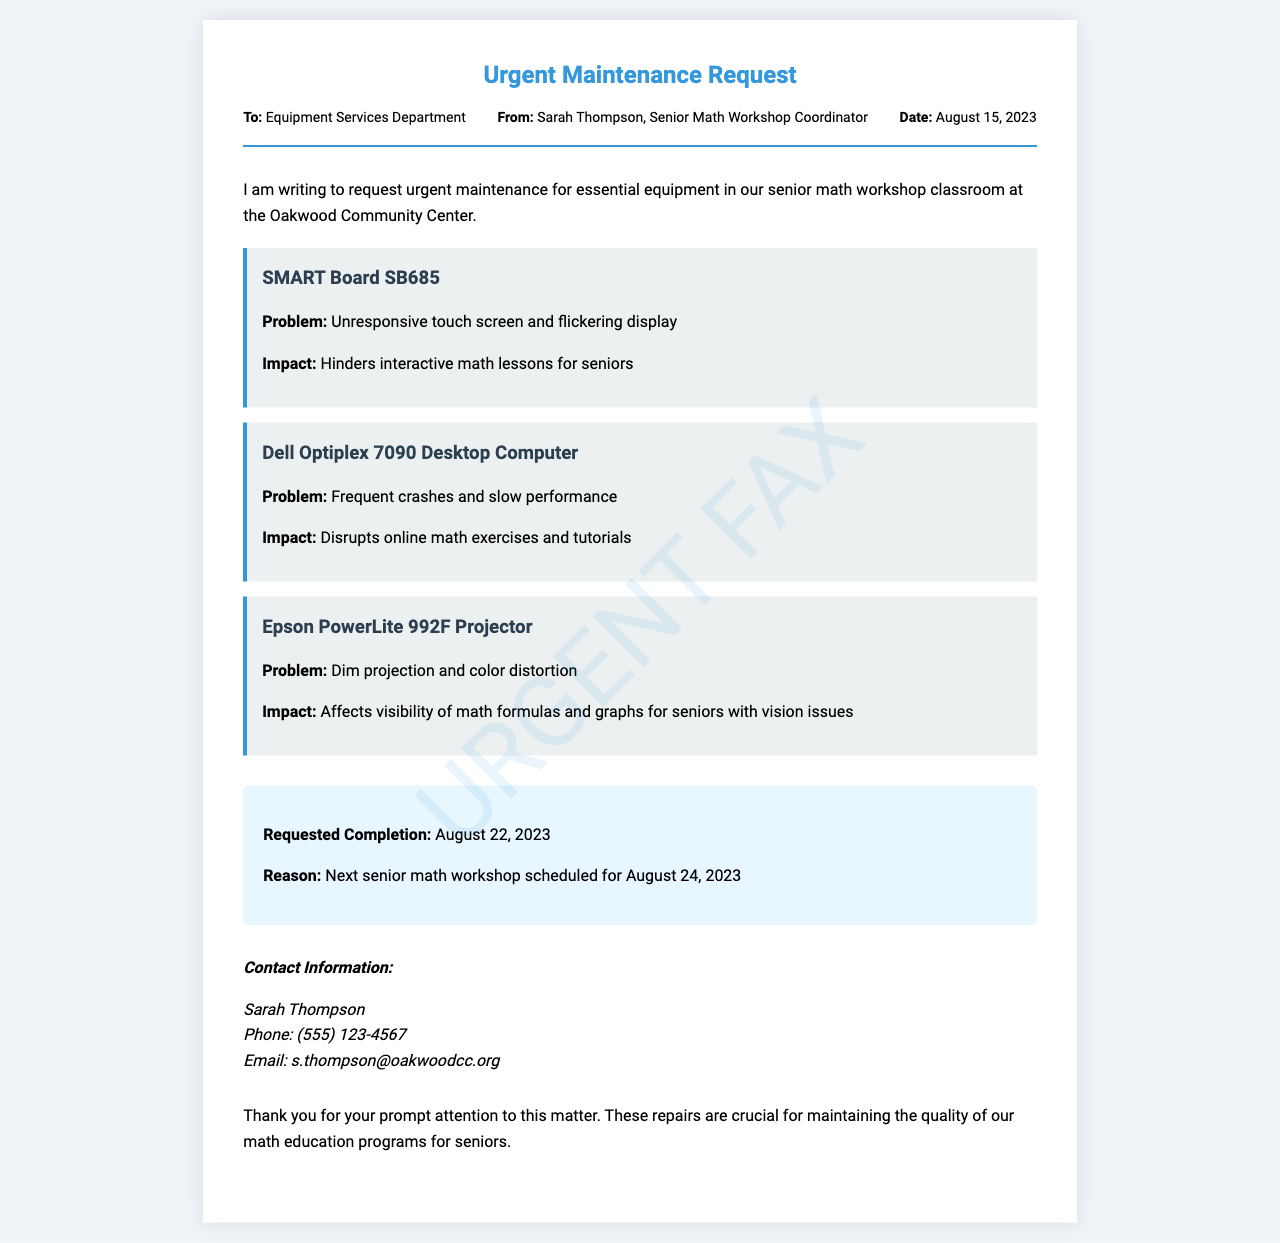What is the date of the urgent maintenance request? The date mentioned in the document is the specific day the request was made, which is August 15, 2023.
Answer: August 15, 2023 Who is the sender of the fax? The sender of the fax is identified as Sarah Thompson, who is the Senior Math Workshop Coordinator.
Answer: Sarah Thompson What equipment is having issues with an unresponsive touch screen? The document describes the SMART Board SB685 as having an unresponsive touch screen problem.
Answer: SMART Board SB685 What is the requested completion date for the repairs? The requested completion date is noted in the document as a specific deadline for the equipment repairs, which is August 22, 2023.
Answer: August 22, 2023 What is the impact of the Dell Optiplex 7090 Desktop Computer issue? The impact is described in the document as disrupting online math exercises and tutorials.
Answer: Disrupts online math exercises and tutorials What is the color distortion issue affecting? The impact of the Epson PowerLite 992F Projector issue affects visibility of math formulas and graphs, particularly for seniors with vision issues.
Answer: Visibility of math formulas and graphs for seniors with vision issues When is the next scheduled senior math workshop? The document states the next senior math workshop is scheduled for August 24, 2023.
Answer: August 24, 2023 What is the main purpose of this fax? The main purpose is to request urgent maintenance for essential equipment used in the senior math workshop classroom.
Answer: Request urgent maintenance for essential equipment 